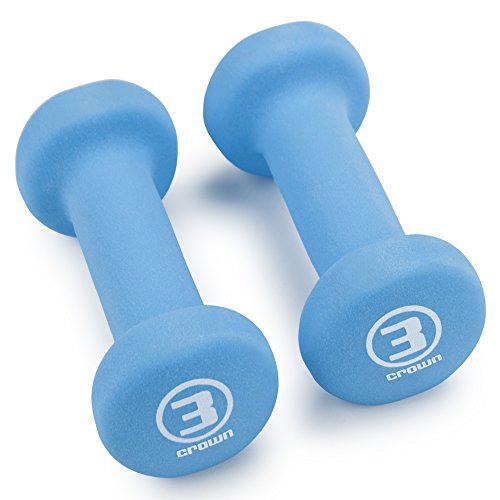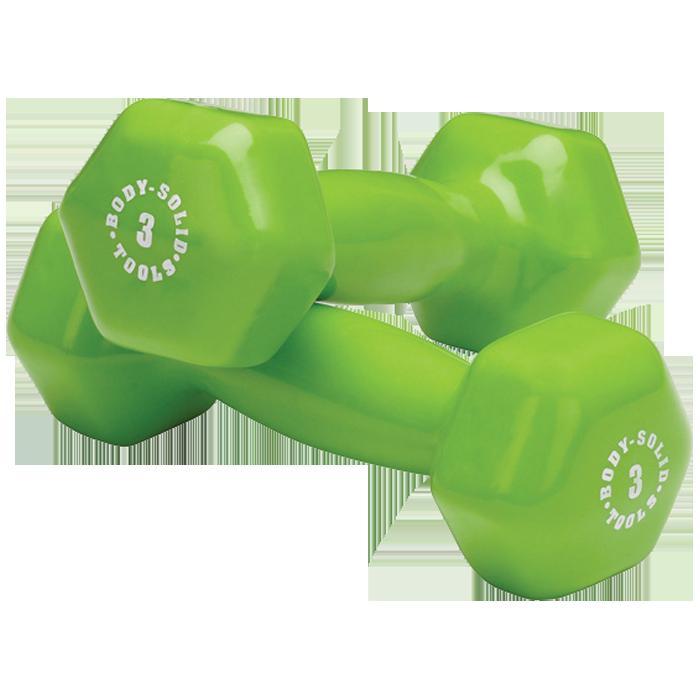The first image is the image on the left, the second image is the image on the right. Given the left and right images, does the statement "The right image contains two small pink exercise weights." hold true? Answer yes or no. No. The first image is the image on the left, the second image is the image on the right. For the images displayed, is the sentence "The right image shows a pair of pink free weights with one weight resting slightly atop the other" factually correct? Answer yes or no. No. 